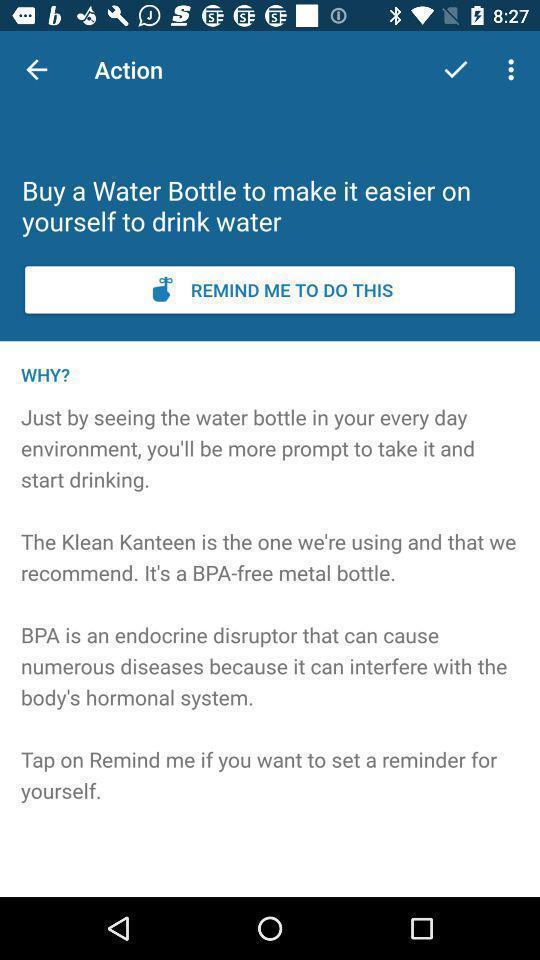Provide a textual representation of this image. Window displaying reminder for yourself. 